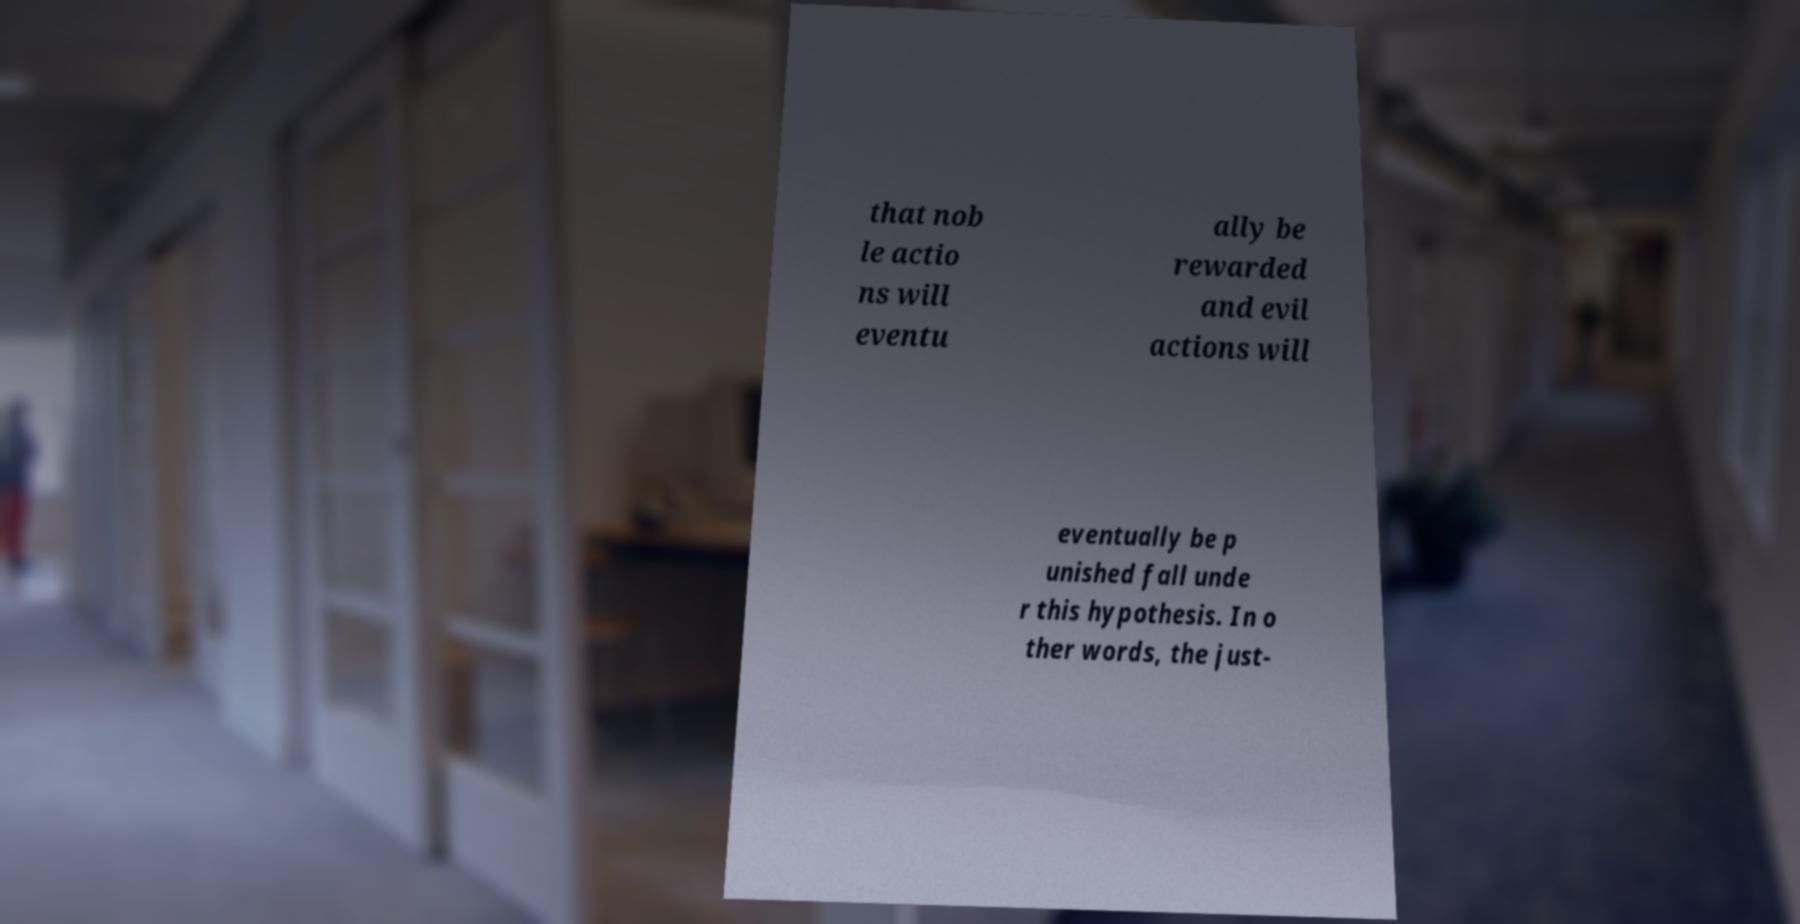Please read and relay the text visible in this image. What does it say? that nob le actio ns will eventu ally be rewarded and evil actions will eventually be p unished fall unde r this hypothesis. In o ther words, the just- 